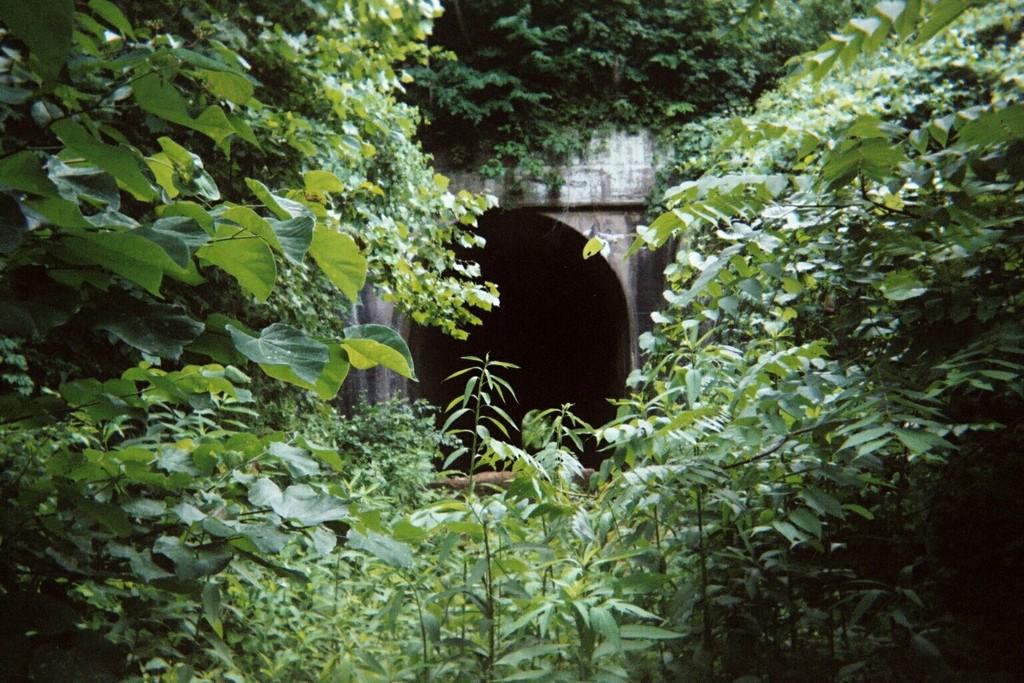What is the main subject in the middle of the image? There is a small tunnel in the middle of the image. What can be seen surrounding the tunnel? There are many green trees and leaves around the tunnel. What type of lock is used to secure the tunnel in the image? There is no lock present in the image; it is a tunnel surrounded by trees and leaves. 